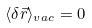<formula> <loc_0><loc_0><loc_500><loc_500>\langle \delta \vec { r } \rangle _ { v a c } = 0</formula> 